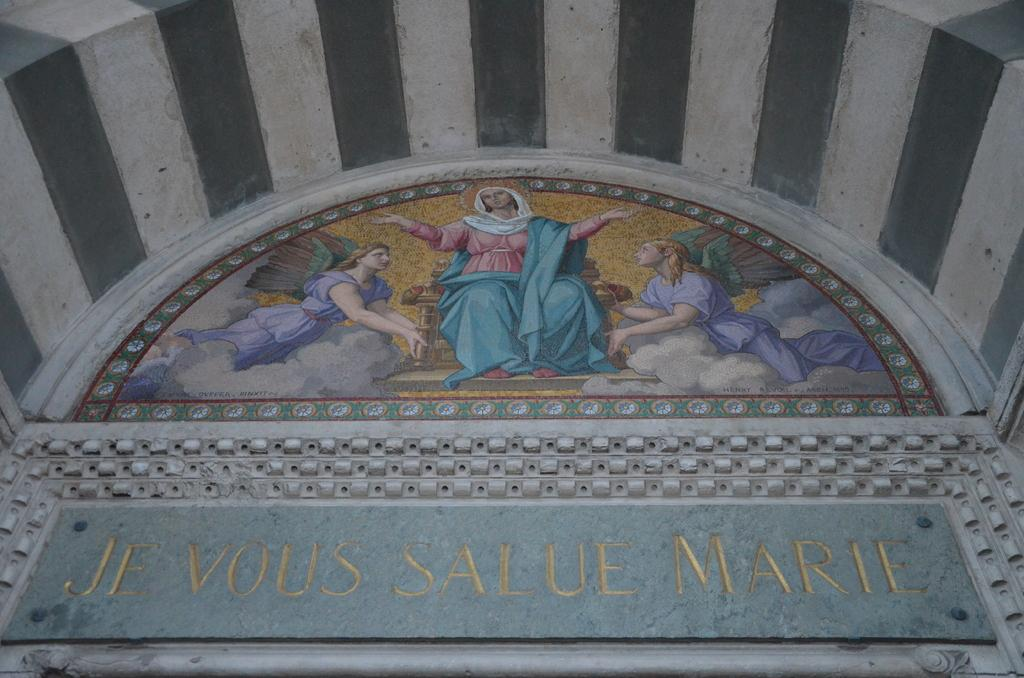What is present on the wall in the image? There is a wall in the image, and on it, there are paintings of people and text. Can you describe the paintings on the wall? The paintings on the wall depict people. What else is featured on the wall besides the paintings? There is text on the wall. How many bikes are parked next to the wall in the image? There are no bikes present in the image; the image only features a wall with paintings of people and text. 